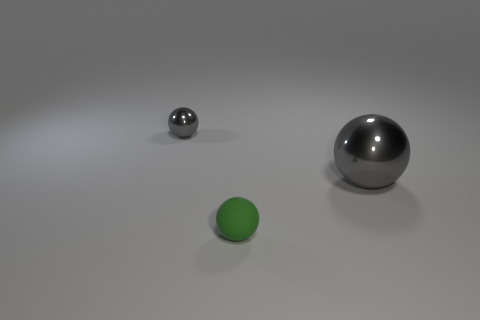What size is the other object that is the same color as the large shiny thing?
Provide a short and direct response. Small. How many other things are there of the same shape as the large gray metallic thing?
Offer a very short reply. 2. There is a gray sphere that is behind the shiny ball right of the tiny gray sphere; what is its material?
Give a very brief answer. Metal. There is a tiny gray ball; are there any big gray things to the left of it?
Give a very brief answer. No. There is a rubber sphere; is its size the same as the gray metal ball that is in front of the tiny gray shiny thing?
Keep it short and to the point. No. What size is the other metallic object that is the same shape as the small metallic thing?
Your answer should be very brief. Large. Are there any other things that are the same material as the green sphere?
Your answer should be compact. No. Do the gray metal object on the left side of the green rubber sphere and the green thing in front of the big gray thing have the same size?
Your answer should be very brief. Yes. How many big things are either gray metal things or cyan spheres?
Keep it short and to the point. 1. What number of shiny things are behind the large ball and in front of the small metal sphere?
Ensure brevity in your answer.  0. 